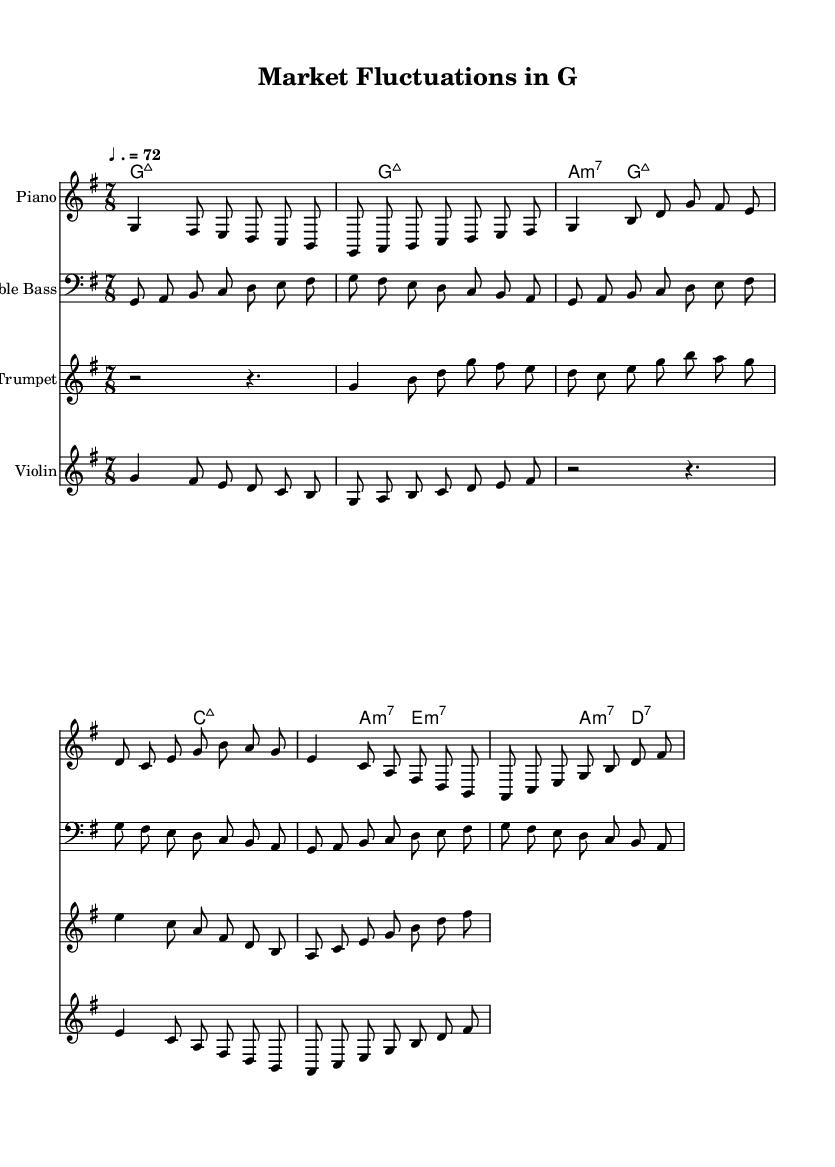What is the key signature of this music? The key signature is G major, which has one sharp (F#). This can be identified at the beginning of the score, where the key signature is indicated.
Answer: G major What is the time signature of this music? The time signature is 7/8. This is shown at the beginning of the score, indicating that there are seven eighth notes in each measure.
Answer: 7/8 What is the tempo marking of this music? The tempo marking is indicated as ♩. = 72, meaning that the quarter note should be played at a speed of 72 beats per minute. This is typically found at the beginning of the score.
Answer: 72 How many instruments are used in this composition? There are four instruments indicated in the score: Piano, Double Bass, Trumpet, and Violin. This can be determined by counting the staff sections labeled with the respective instrument names.
Answer: Four Which chords are present in the piano part? The chord symbols listed are G major 7, A minor 7, C major 7, and D7. These chords appear in the chord names section and inform about the harmonic structure while playing.
Answer: G major 7, A minor 7, C major 7, D7 What is the rhythm pattern used in the first measure for the piano? The rhythm pattern consists of a combination of quarter and eighth notes. The first note is a quarter note followed by two eighth notes, which creates an offbeat feel typical in jazz. This is evident in the notation of the first measure.
Answer: Quarter and eighth notes Is there a rest in the trumpet part, and if so, how long? Yes, there is a half note rest followed by a quarter note rest at the start of the trumpet part. The rest can be seen as an indicator for silence at the beginning of the trumpet line.
Answer: Half note 